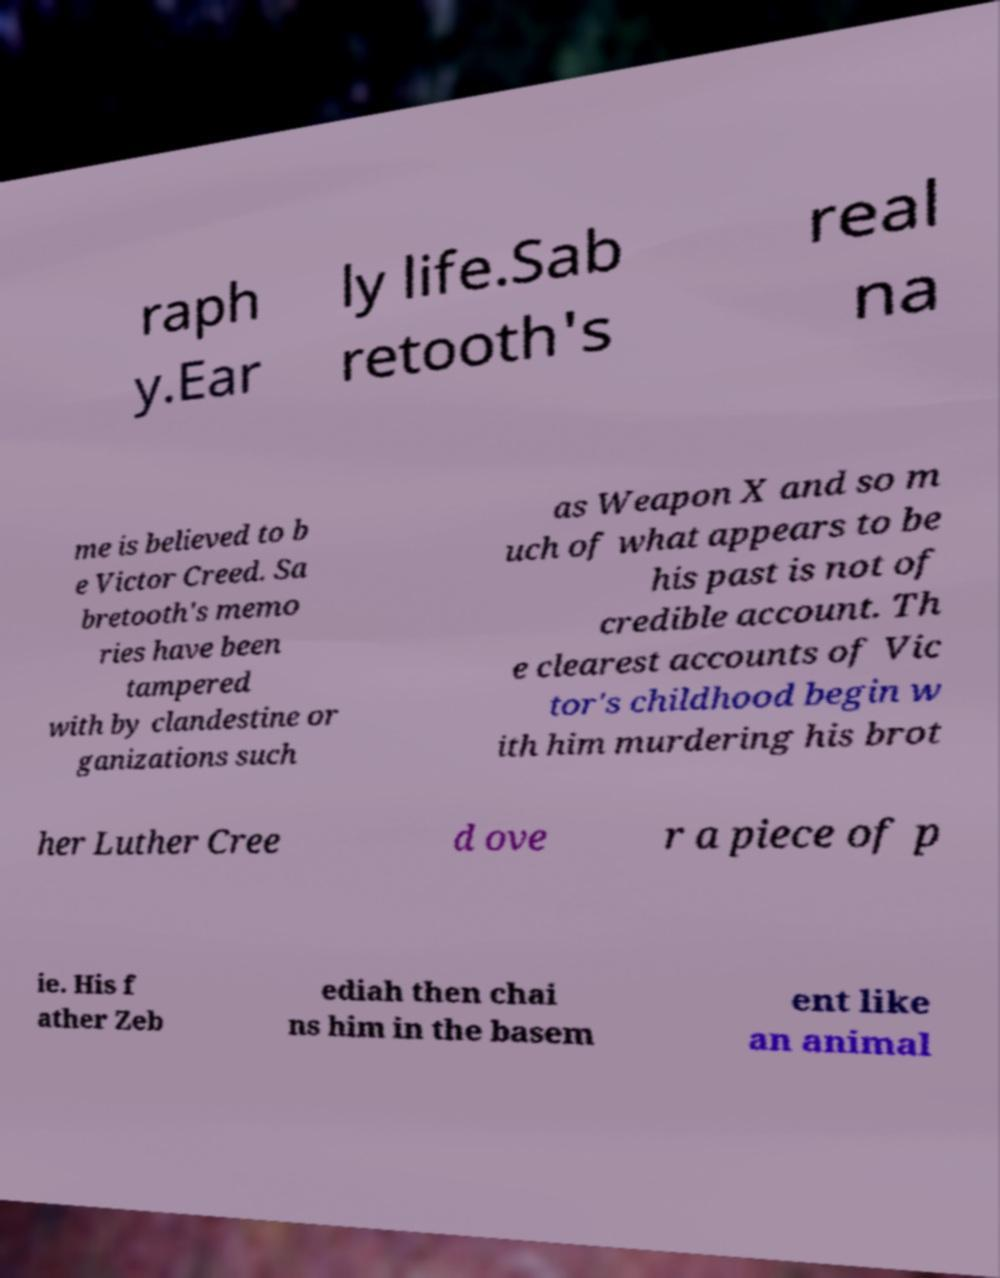For documentation purposes, I need the text within this image transcribed. Could you provide that? raph y.Ear ly life.Sab retooth's real na me is believed to b e Victor Creed. Sa bretooth's memo ries have been tampered with by clandestine or ganizations such as Weapon X and so m uch of what appears to be his past is not of credible account. Th e clearest accounts of Vic tor's childhood begin w ith him murdering his brot her Luther Cree d ove r a piece of p ie. His f ather Zeb ediah then chai ns him in the basem ent like an animal 